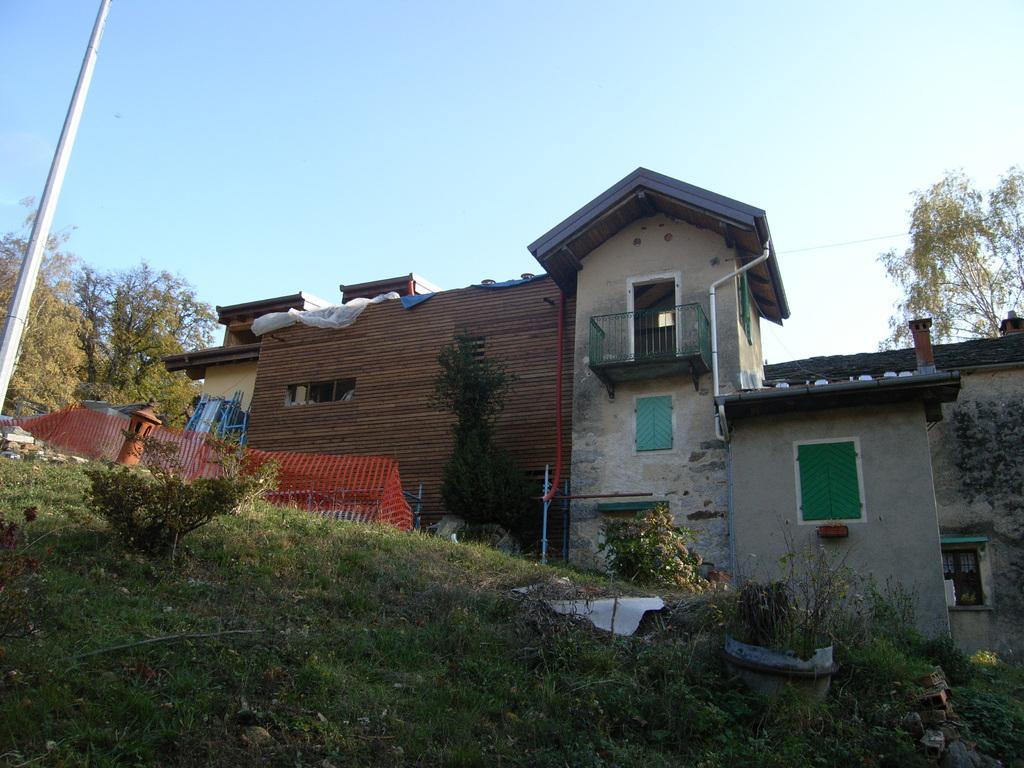How would you summarize this image in a sentence or two? In the picture I can see a greenery ground which has few plants on it and there is a red color fence,a pole and trees in the left corner and there is a building in the background. 